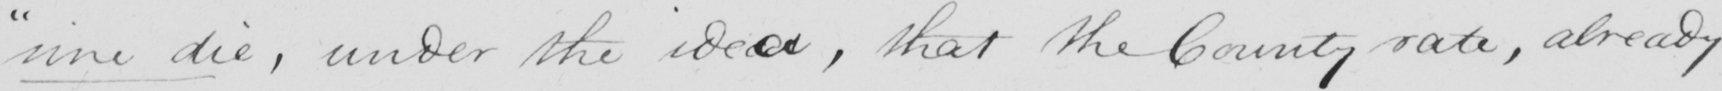Can you read and transcribe this handwriting? " sine die , under the idea , that the County rate , already 